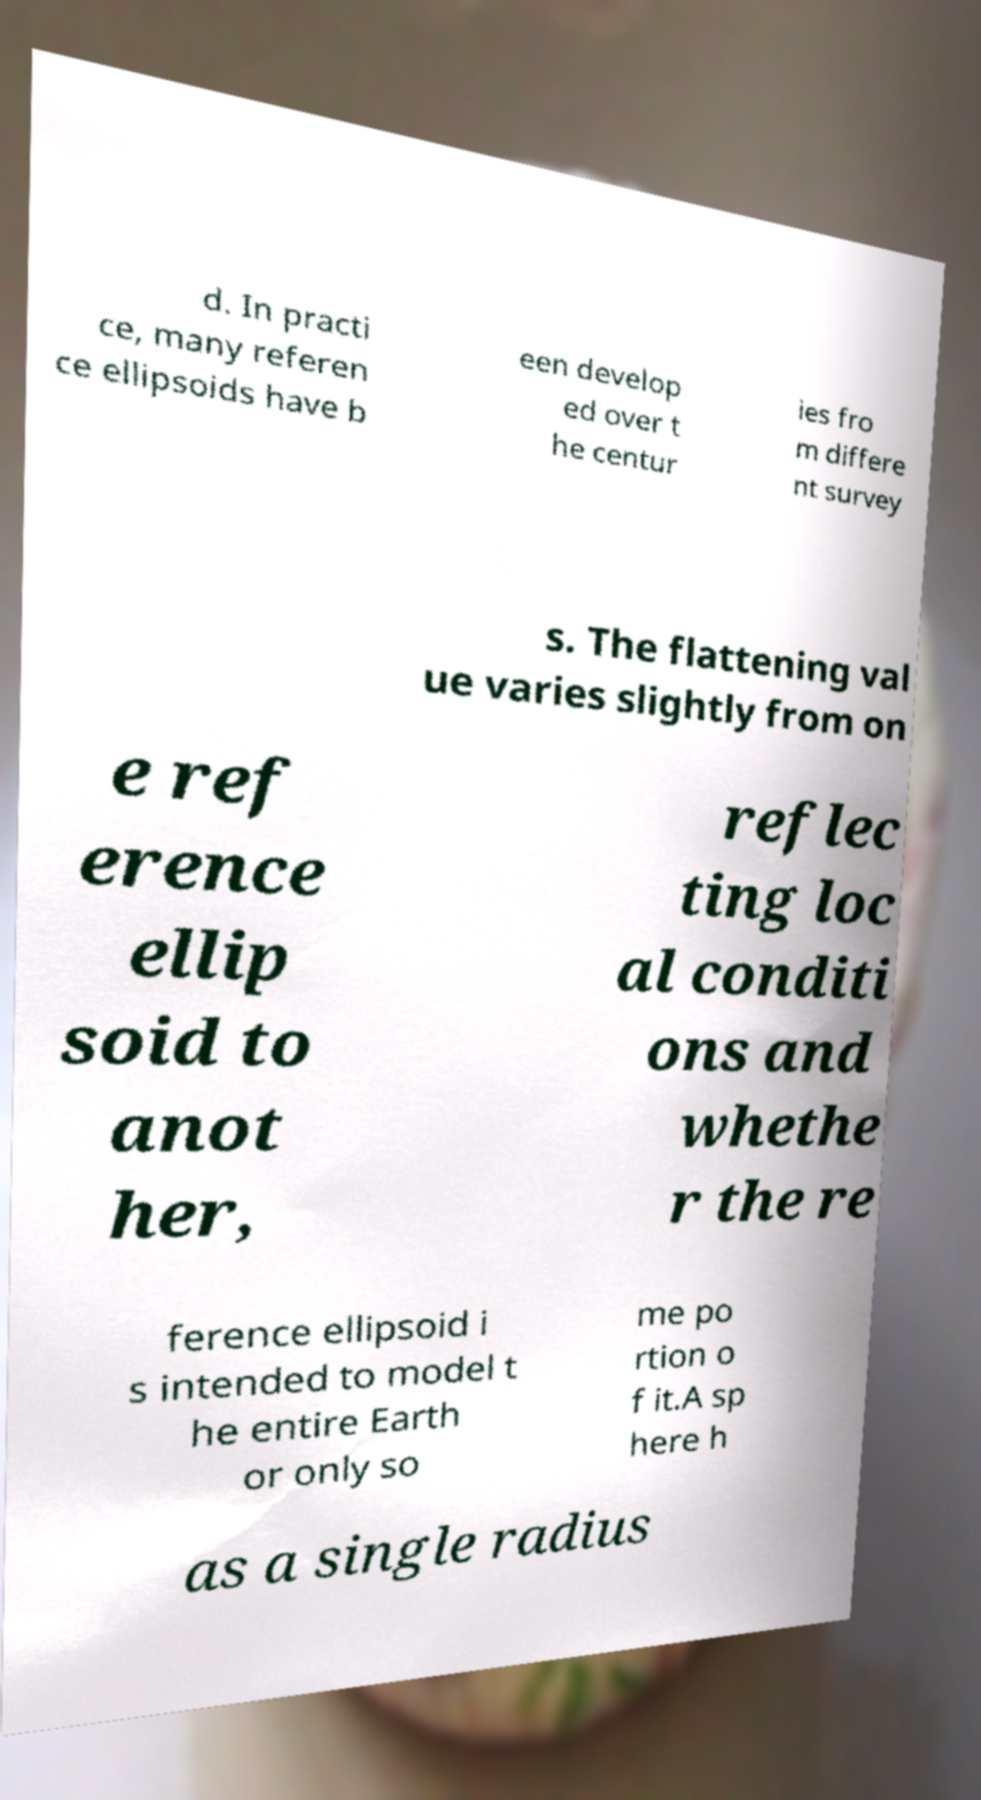Please read and relay the text visible in this image. What does it say? d. In practi ce, many referen ce ellipsoids have b een develop ed over t he centur ies fro m differe nt survey s. The flattening val ue varies slightly from on e ref erence ellip soid to anot her, reflec ting loc al conditi ons and whethe r the re ference ellipsoid i s intended to model t he entire Earth or only so me po rtion o f it.A sp here h as a single radius 